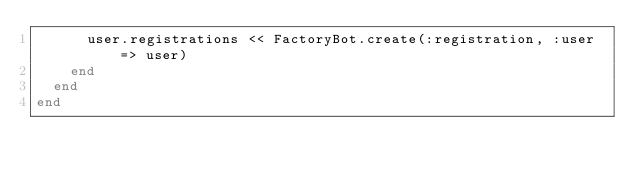<code> <loc_0><loc_0><loc_500><loc_500><_Ruby_>      user.registrations << FactoryBot.create(:registration, :user => user)
    end
  end
end
</code> 